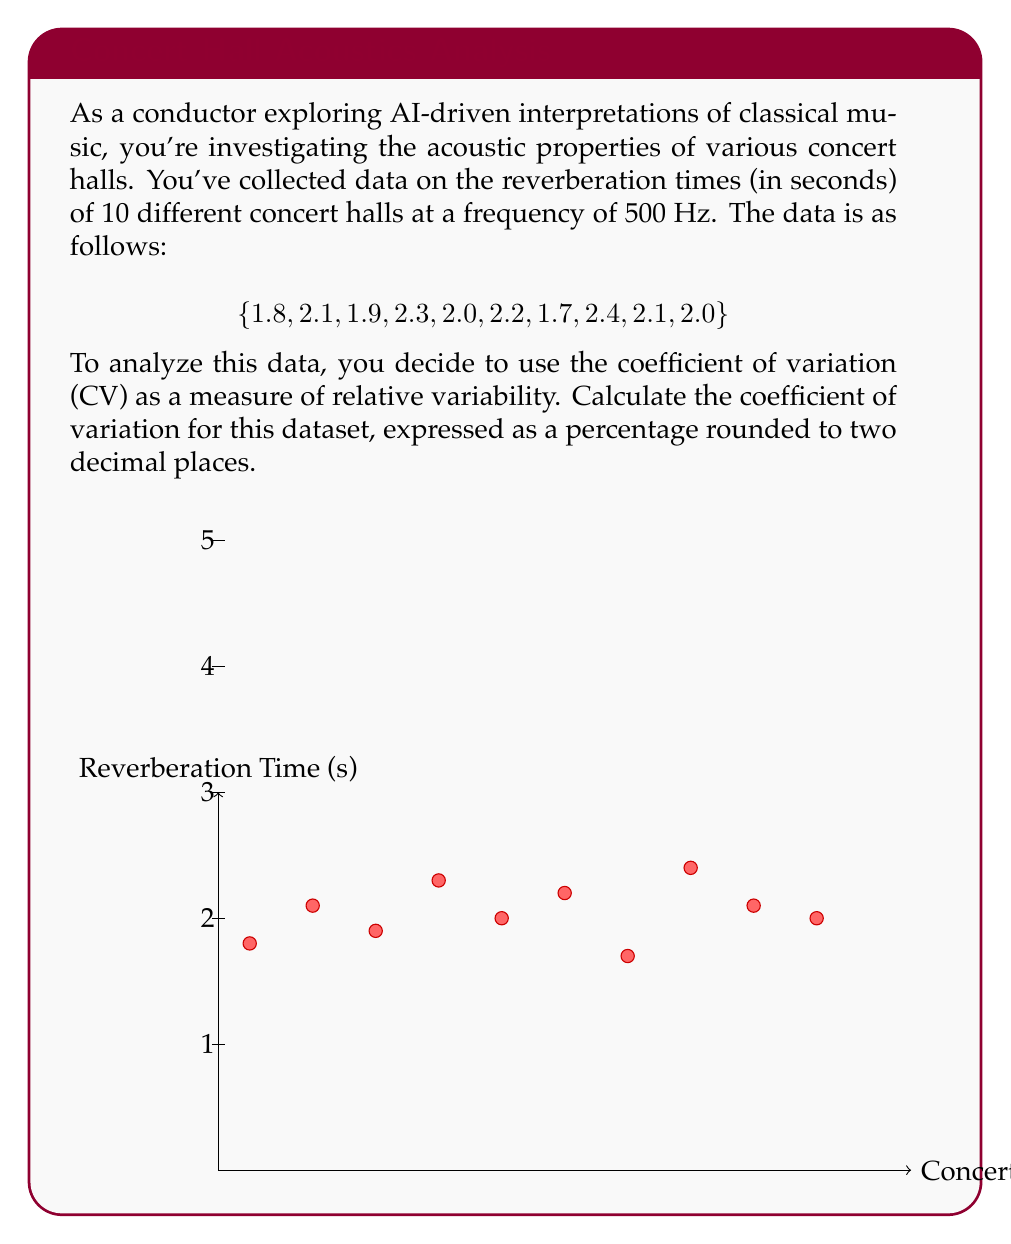Show me your answer to this math problem. To calculate the coefficient of variation (CV), we need to follow these steps:

1. Calculate the mean ($\mu$) of the dataset:
   $$\mu = \frac{\sum_{i=1}^{n} x_i}{n} = \frac{1.8 + 2.1 + 1.9 + 2.3 + 2.0 + 2.2 + 1.7 + 2.4 + 2.1 + 2.0}{10} = \frac{20.5}{10} = 2.05$$

2. Calculate the standard deviation ($\sigma$):
   First, we need to calculate the variance:
   $$\sigma^2 = \frac{\sum_{i=1}^{n} (x_i - \mu)^2}{n-1}$$
   
   $$(1.8-2.05)^2 + (2.1-2.05)^2 + ... + (2.0-2.05)^2 = 0.425$$
   
   $$\sigma^2 = \frac{0.425}{9} = 0.04722$$
   
   Then, take the square root to get the standard deviation:
   $$\sigma = \sqrt{0.04722} = 0.2173$$

3. Calculate the coefficient of variation:
   $$CV = \frac{\sigma}{\mu} \times 100\%$$
   
   $$CV = \frac{0.2173}{2.05} \times 100\% = 10.60\%$$

4. Round to two decimal places: 10.60%
Answer: 10.60% 